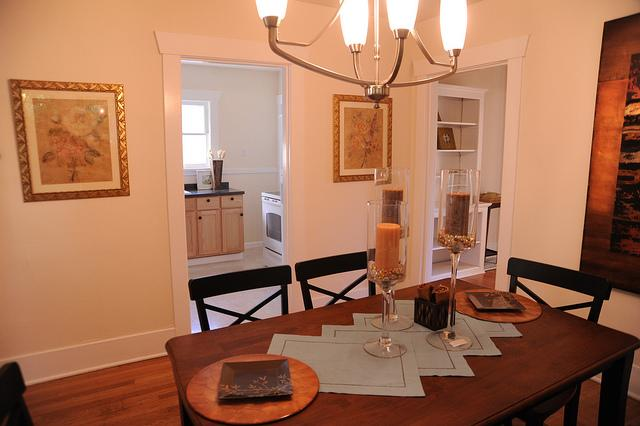What is inside the tall glasses? candles 